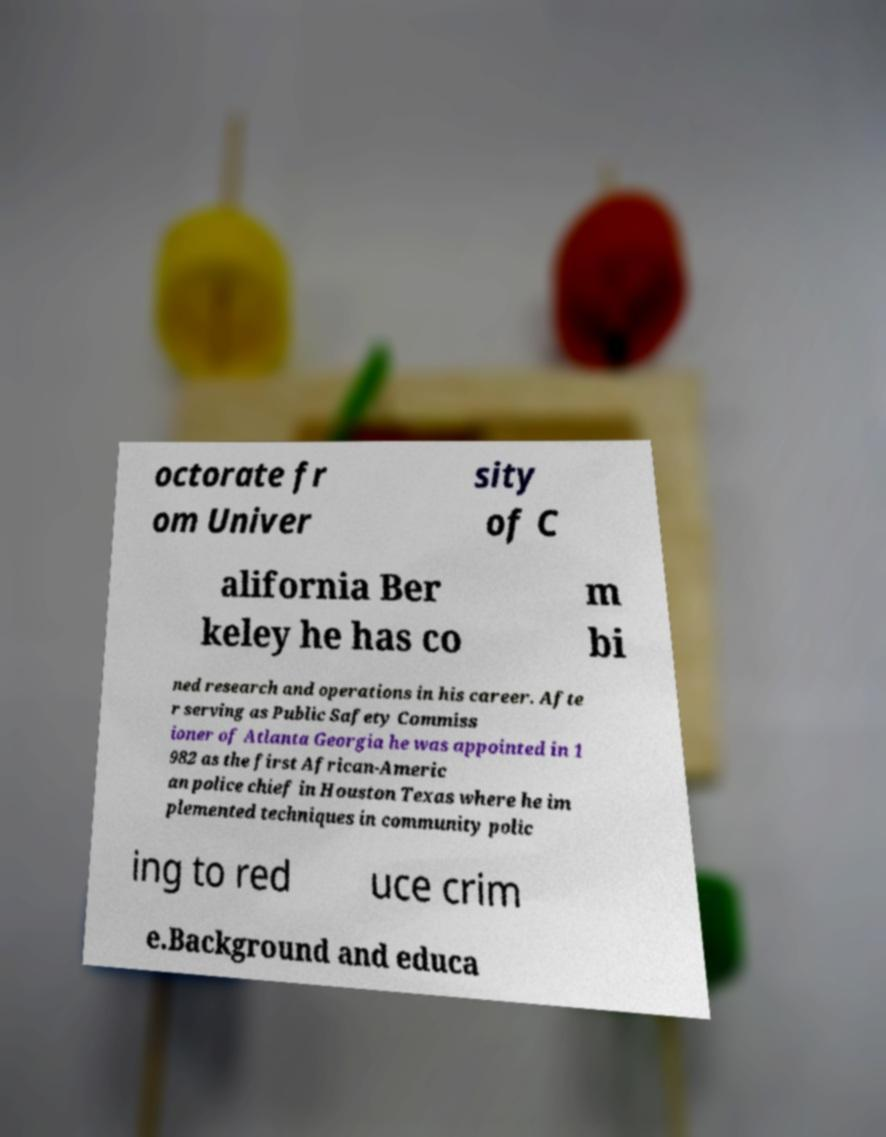Can you read and provide the text displayed in the image?This photo seems to have some interesting text. Can you extract and type it out for me? octorate fr om Univer sity of C alifornia Ber keley he has co m bi ned research and operations in his career. Afte r serving as Public Safety Commiss ioner of Atlanta Georgia he was appointed in 1 982 as the first African-Americ an police chief in Houston Texas where he im plemented techniques in community polic ing to red uce crim e.Background and educa 